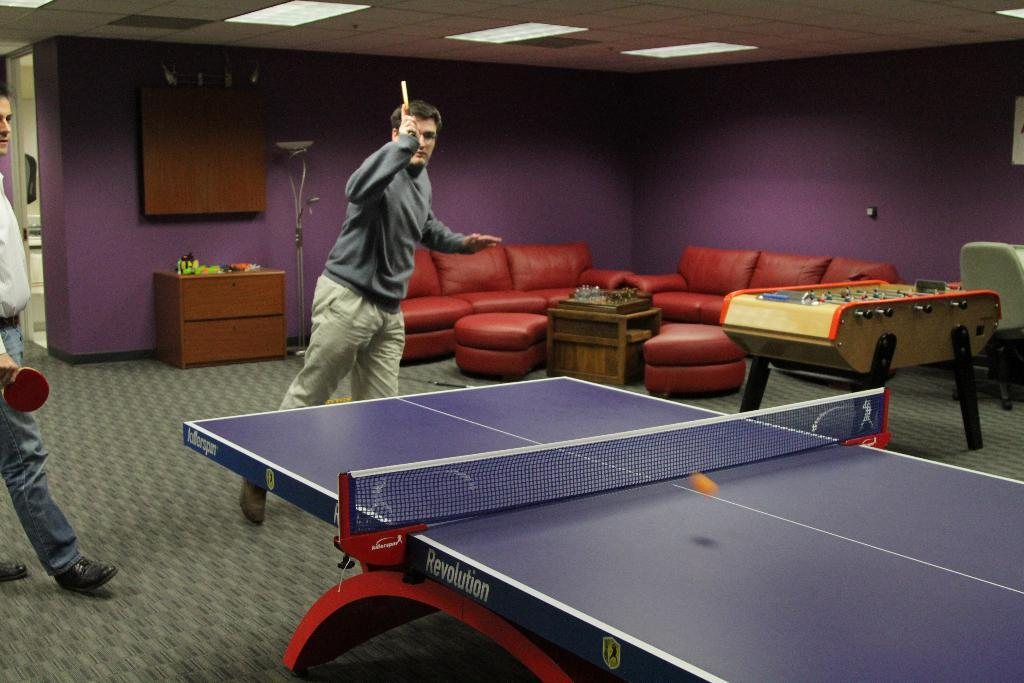What type of room is depicted in the image? The image depicts a room where indoor games are played. What specific game are the two people playing in the room? The two people are playing table tennis in the room. What type of furniture is present in the room? There are sofas in the room. What is the primary piece of furniture used for playing games in the room? There is a table in the room. What other type of game or activity can be played in the room? A gaming board is present in the room. What storage furniture is present in the room? There is a cupboard in the room. What color is the key used to unlock the vein in the image? There is no key or vein present in the image; it depicts a room where indoor games are played. 